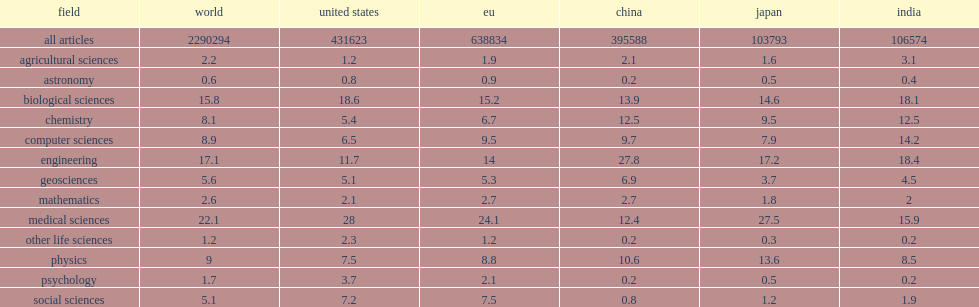On a global scale, how many percent of publications were in journals classified as covering the biological sciences, medical sciences, or other life sciences? 39.1. How many percent did engineering publications make up of the global output? 17.1. How many percent did researchers in the united states produce a proportion of publications in psychology? 3.7. How many percent did researchers in the united states produce a proportion of publications in social sciences? 7.2. How many percent did japan had larger publication shares in the fields of chemistry? 9.5. How many percent did japan had larger publication shares in the fields of physics? 13.6. China's research portfolio showed a different pattern than the one for the united states and the world, how many percent of a greater focus on engineering? 27.8. China's research portfolio showed a different pattern than the one for the united states and the world, how many percent of a greater focus on chemistry? 12.5. 